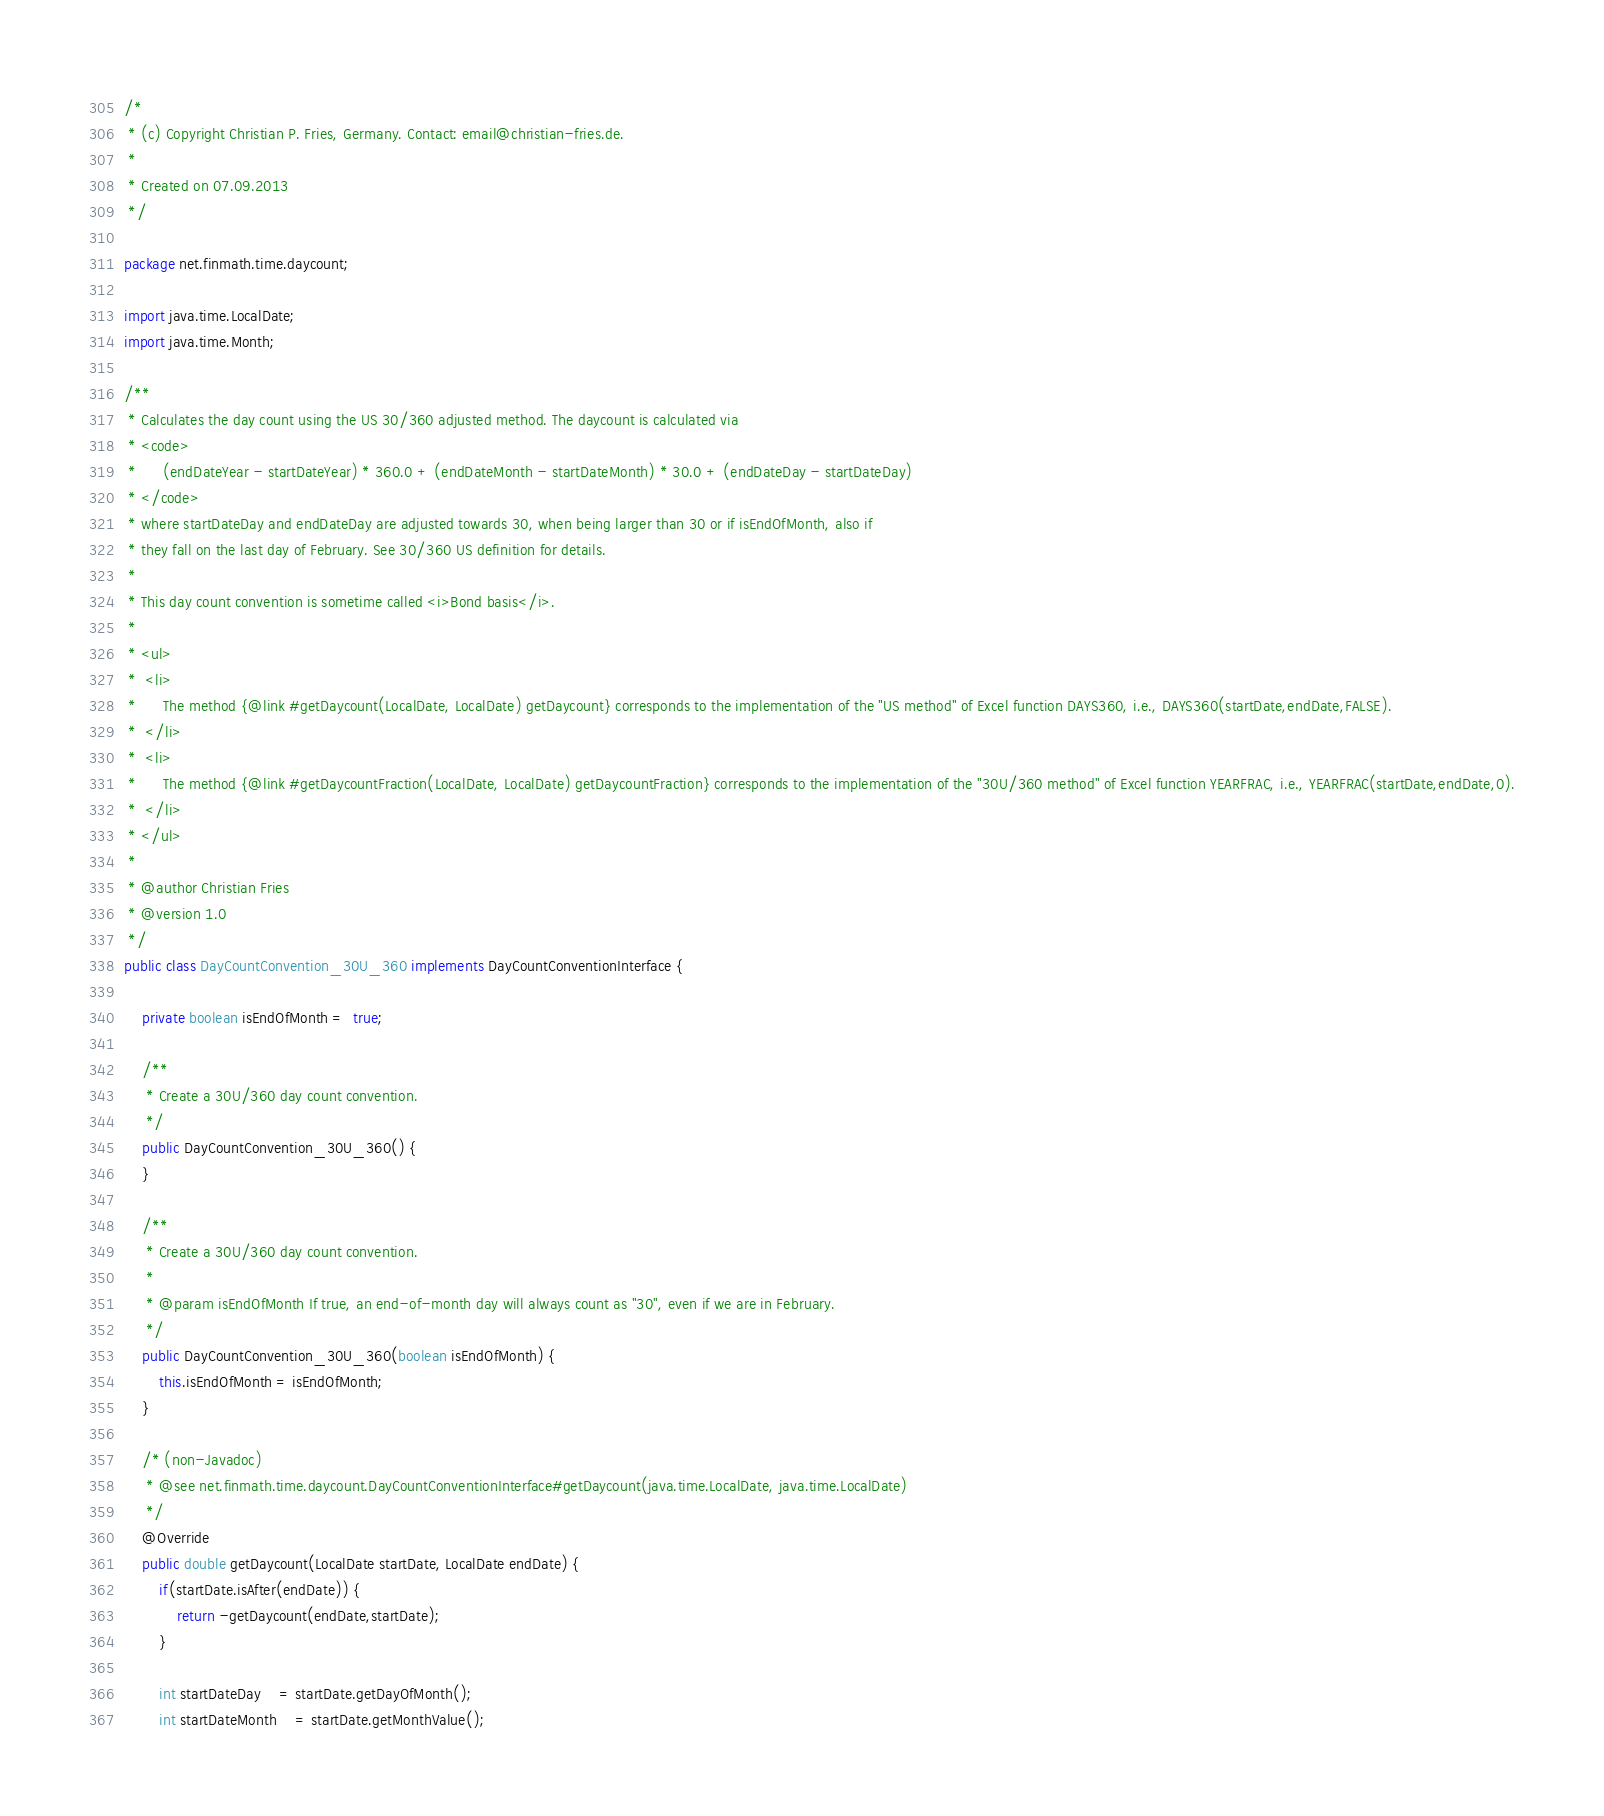<code> <loc_0><loc_0><loc_500><loc_500><_Java_>/*
 * (c) Copyright Christian P. Fries, Germany. Contact: email@christian-fries.de.
 *
 * Created on 07.09.2013
 */

package net.finmath.time.daycount;

import java.time.LocalDate;
import java.time.Month;

/**
 * Calculates the day count using the US 30/360 adjusted method. The daycount is calculated via
 * <code>
 *		(endDateYear - startDateYear) * 360.0 + (endDateMonth - startDateMonth) * 30.0 + (endDateDay - startDateDay)
 * </code>
 * where startDateDay and endDateDay are adjusted towards 30, when being larger than 30 or if isEndOfMonth, also if
 * they fall on the last day of February. See 30/360 US definition for details.
 *
 * This day count convention is sometime called <i>Bond basis</i>.
 *
 * <ul>
 * 	<li>
 * 		The method {@link #getDaycount(LocalDate, LocalDate) getDaycount} corresponds to the implementation of the "US method" of Excel function DAYS360, i.e., DAYS360(startDate,endDate,FALSE).
 * 	</li>
 * 	<li>
 * 		The method {@link #getDaycountFraction(LocalDate, LocalDate) getDaycountFraction} corresponds to the implementation of the "30U/360 method" of Excel function YEARFRAC, i.e., YEARFRAC(startDate,endDate,0).
 * 	</li>
 * </ul>
 *
 * @author Christian Fries
 * @version 1.0
 */
public class DayCountConvention_30U_360 implements DayCountConventionInterface {

	private boolean isEndOfMonth =  true;

	/**
	 * Create a 30U/360 day count convention.
	 */
	public DayCountConvention_30U_360() {
	}

	/**
	 * Create a 30U/360 day count convention.
	 *
	 * @param isEndOfMonth If true, an end-of-month day will always count as "30", even if we are in February.
	 */
	public DayCountConvention_30U_360(boolean isEndOfMonth) {
		this.isEndOfMonth = isEndOfMonth;
	}

	/* (non-Javadoc)
	 * @see net.finmath.time.daycount.DayCountConventionInterface#getDaycount(java.time.LocalDate, java.time.LocalDate)
	 */
	@Override
	public double getDaycount(LocalDate startDate, LocalDate endDate) {
		if(startDate.isAfter(endDate)) {
			return -getDaycount(endDate,startDate);
		}

		int startDateDay 	= startDate.getDayOfMonth();
		int startDateMonth 	= startDate.getMonthValue();</code> 